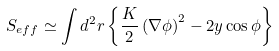<formula> <loc_0><loc_0><loc_500><loc_500>S _ { e f f } \simeq \int d ^ { 2 } r \left \{ \frac { K } { 2 } \left ( \nabla \phi \right ) ^ { 2 } - 2 y \cos \phi \right \}</formula> 